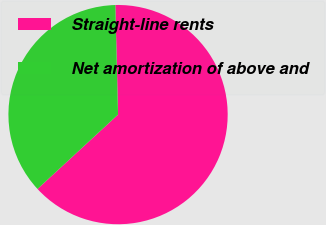Convert chart. <chart><loc_0><loc_0><loc_500><loc_500><pie_chart><fcel>Straight-line rents<fcel>Net amortization of above and<nl><fcel>63.53%<fcel>36.47%<nl></chart> 